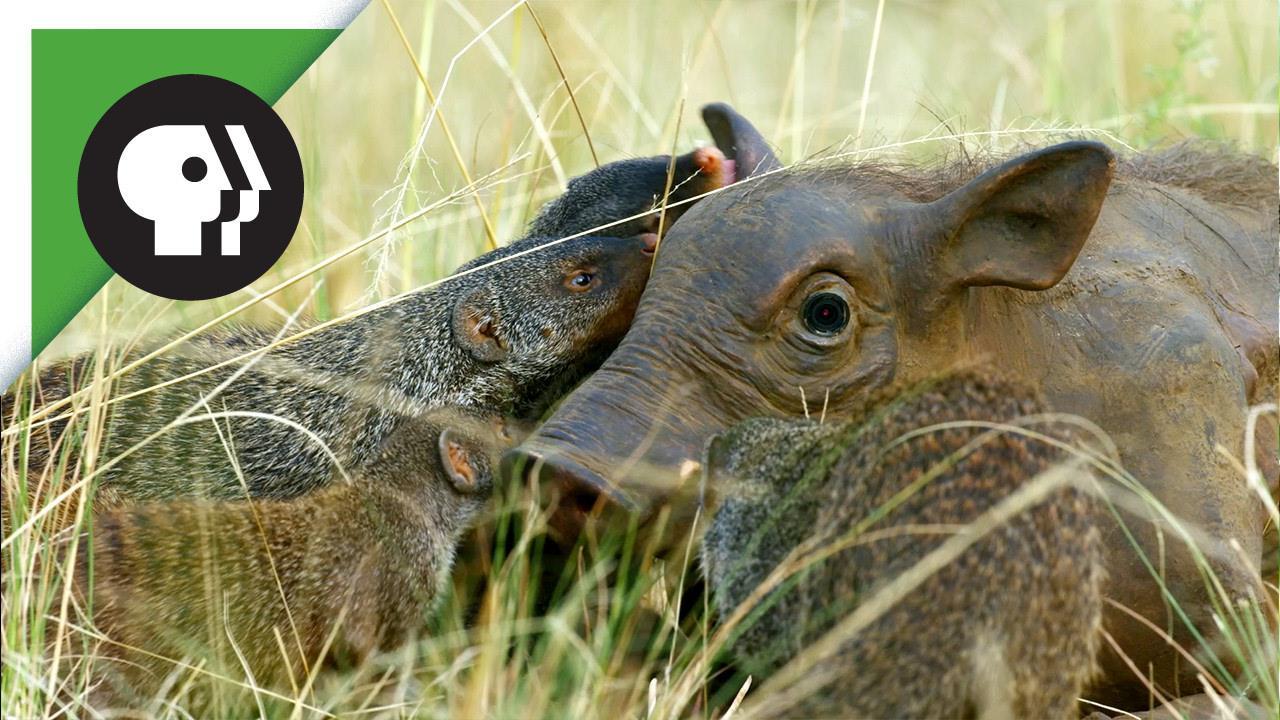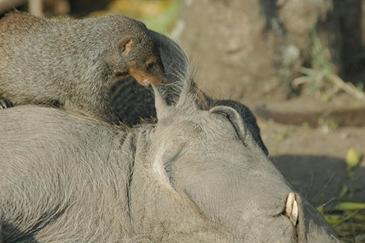The first image is the image on the left, the second image is the image on the right. Assess this claim about the two images: "Each image shows multiple small striped mammals crawling on and around one warthog, and the warthogs in the two images are in the same type of pose.". Correct or not? Answer yes or no. No. 